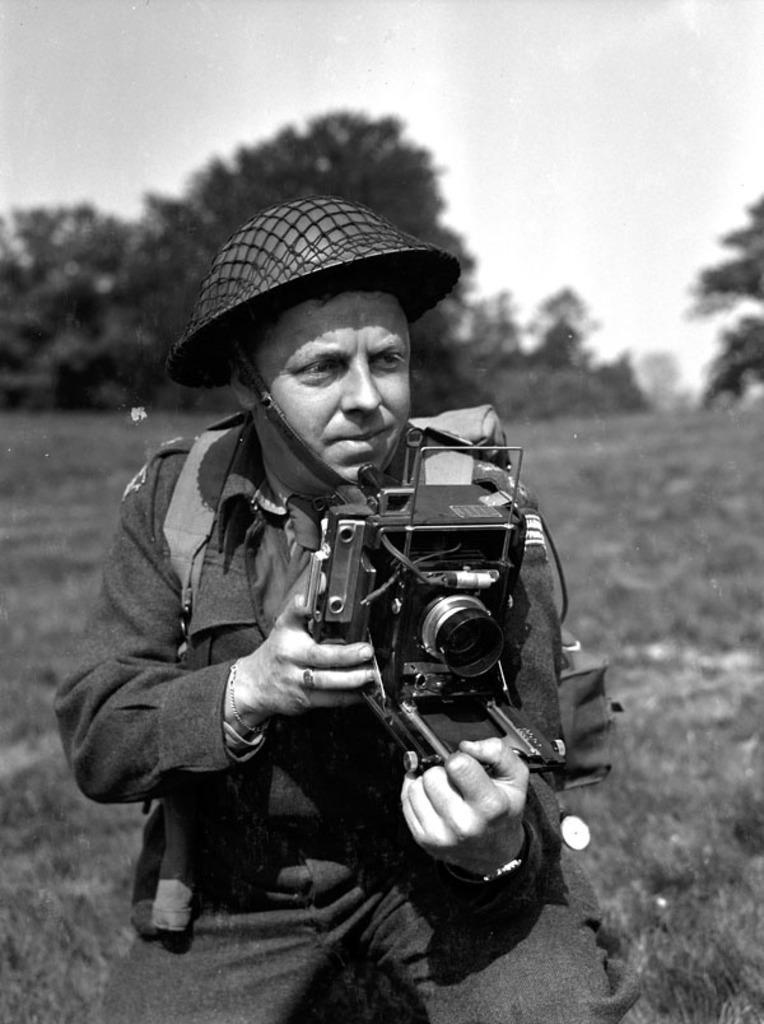How would you summarize this image in a sentence or two? In this picture there is a person at the center of the image who is taking a photograph of the front area of the image, he is wearing a hat around his head and the floor on which he is standing is grass floor and there are some trees around the area of the image. 